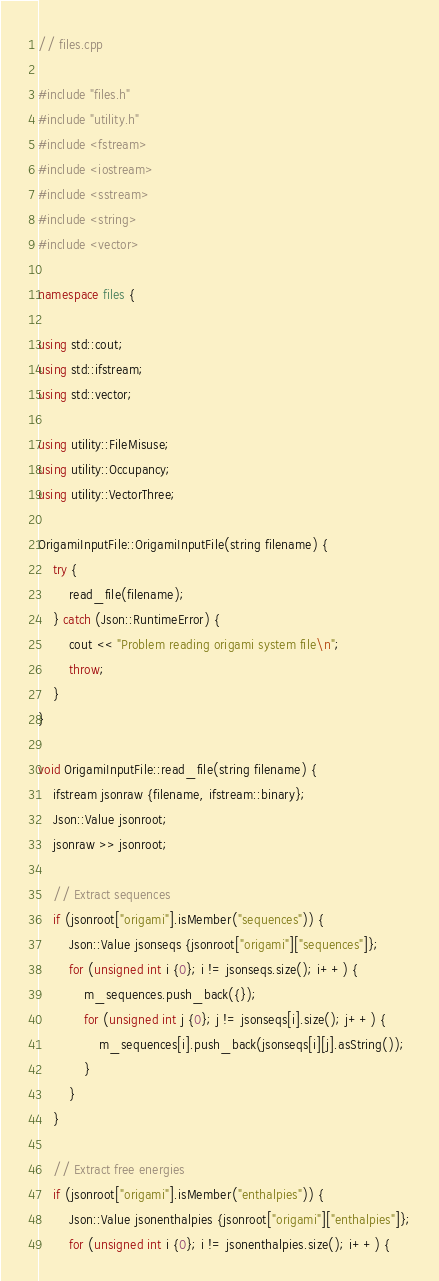Convert code to text. <code><loc_0><loc_0><loc_500><loc_500><_C++_>// files.cpp

#include "files.h"
#include "utility.h"
#include <fstream>
#include <iostream>
#include <sstream>
#include <string>
#include <vector>

namespace files {

using std::cout;
using std::ifstream;
using std::vector;

using utility::FileMisuse;
using utility::Occupancy;
using utility::VectorThree;

OrigamiInputFile::OrigamiInputFile(string filename) {
    try {
        read_file(filename);
    } catch (Json::RuntimeError) {
        cout << "Problem reading origami system file\n";
        throw;
    }
}

void OrigamiInputFile::read_file(string filename) {
    ifstream jsonraw {filename, ifstream::binary};
    Json::Value jsonroot;
    jsonraw >> jsonroot;

    // Extract sequences
    if (jsonroot["origami"].isMember("sequences")) {
        Json::Value jsonseqs {jsonroot["origami"]["sequences"]};
        for (unsigned int i {0}; i != jsonseqs.size(); i++) {
            m_sequences.push_back({});
            for (unsigned int j {0}; j != jsonseqs[i].size(); j++) {
                m_sequences[i].push_back(jsonseqs[i][j].asString());
            }
        }
    }

    // Extract free energies
    if (jsonroot["origami"].isMember("enthalpies")) {
        Json::Value jsonenthalpies {jsonroot["origami"]["enthalpies"]};
        for (unsigned int i {0}; i != jsonenthalpies.size(); i++) {</code> 